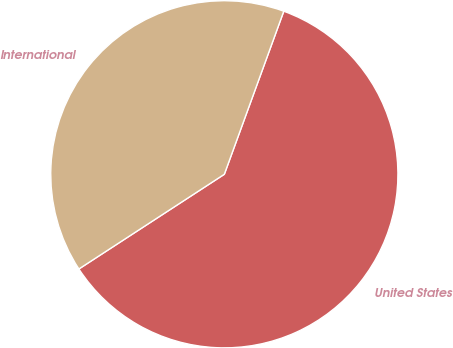<chart> <loc_0><loc_0><loc_500><loc_500><pie_chart><fcel>United States<fcel>International<nl><fcel>60.25%<fcel>39.75%<nl></chart> 